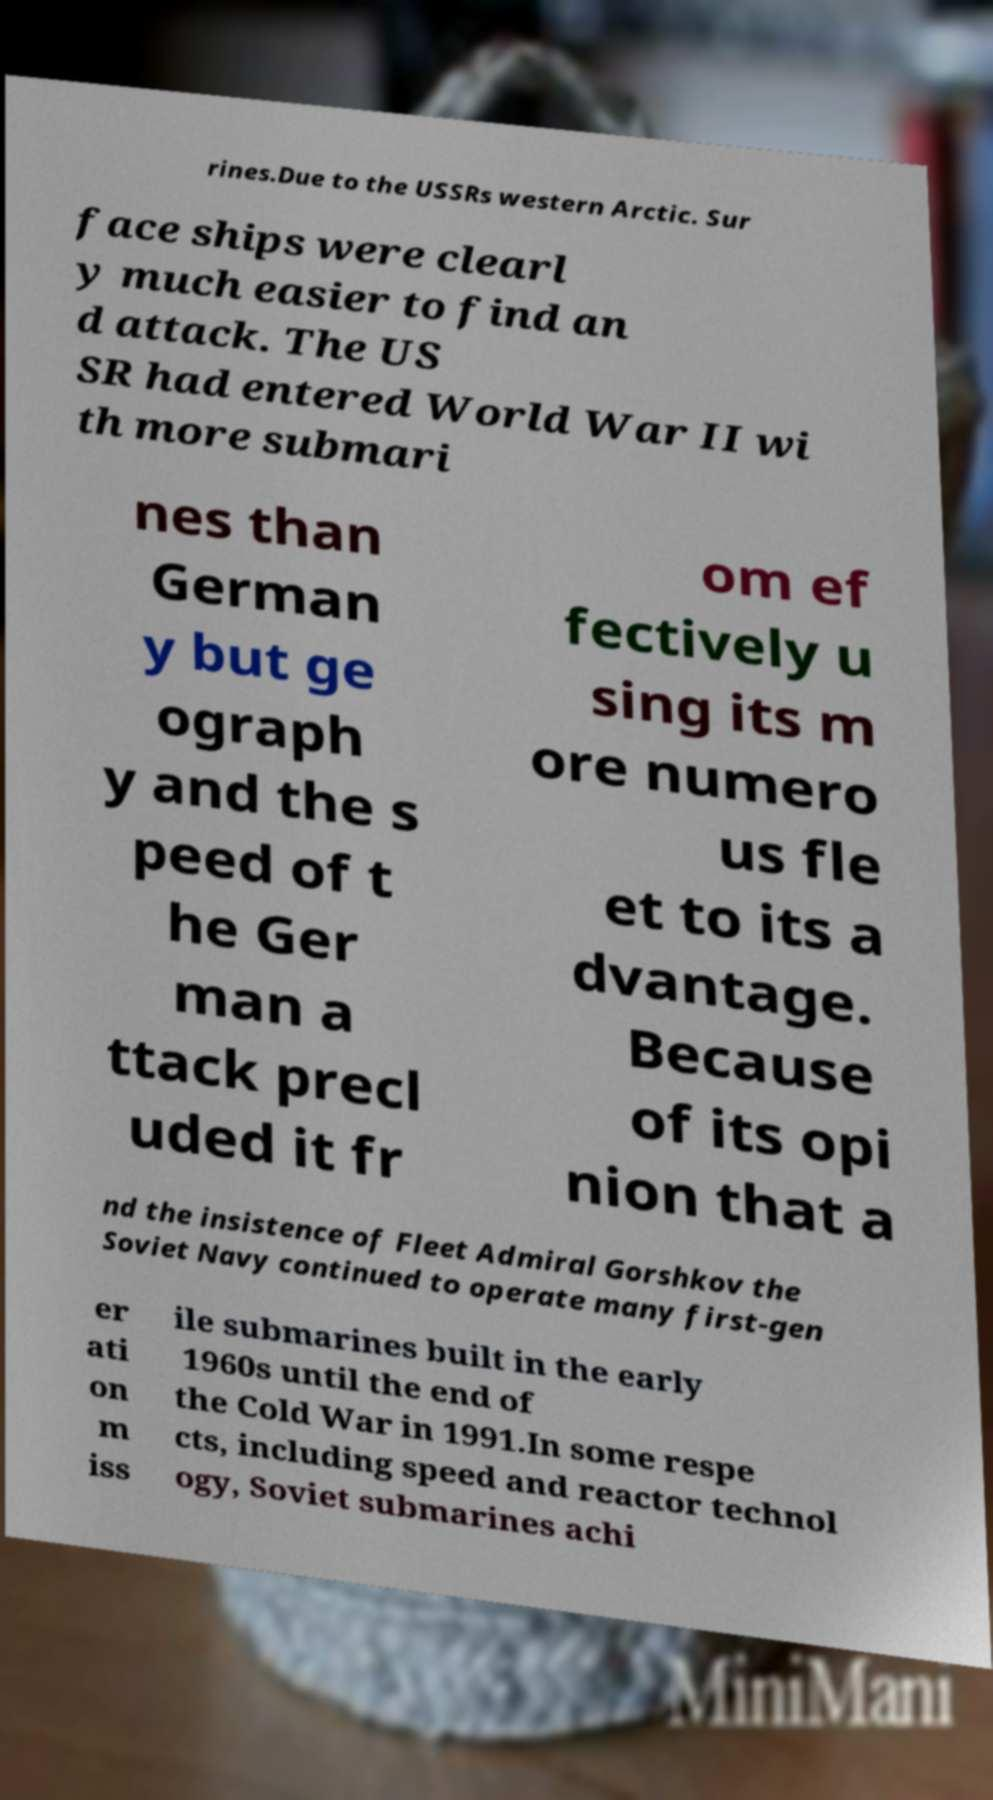Please identify and transcribe the text found in this image. rines.Due to the USSRs western Arctic. Sur face ships were clearl y much easier to find an d attack. The US SR had entered World War II wi th more submari nes than German y but ge ograph y and the s peed of t he Ger man a ttack precl uded it fr om ef fectively u sing its m ore numero us fle et to its a dvantage. Because of its opi nion that a nd the insistence of Fleet Admiral Gorshkov the Soviet Navy continued to operate many first-gen er ati on m iss ile submarines built in the early 1960s until the end of the Cold War in 1991.In some respe cts, including speed and reactor technol ogy, Soviet submarines achi 